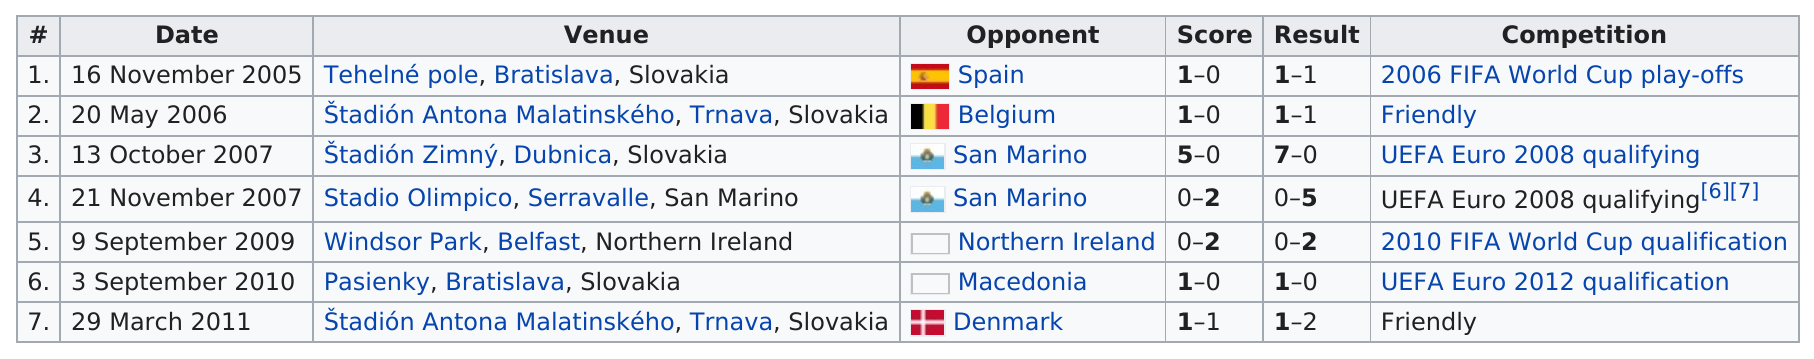Outline some significant characteristics in this image. The first international competition took place on 16 November 2005. San Marino was an opponent a total of two times. The Štadión Antona Malatinského in Trnava, Slovakia was the venue that was used the most. On October 2007, the number of goals scored against San Marino was 5. The venue for the last competition was named Štadión Antona Malatinského, located in Trnava, Slovakia. 